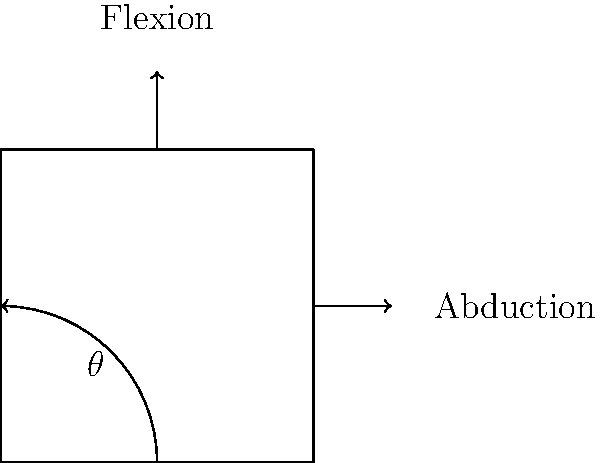In the context of online therapy using digital devices, what is the typical range of motion (ROM) for wrist flexion and abduction when interacting with a smartphone or tablet? How might this impact the effectiveness of hand exercises or gestures used in digital therapy interventions? To answer this question, we need to consider the biomechanics of wrist movements during interaction with digital devices:

1. Wrist Flexion:
   - Normal ROM: Approximately 60-80 degrees
   - When using a smartphone or tablet: Typically 10-30 degrees
   - Reduced ROM due to device support and ergonomic constraints

2. Wrist Abduction:
   - Normal ROM: Approximately 15-20 degrees (radial deviation) and 30-35 degrees (ulnar deviation)
   - When using a smartphone or tablet: Typically 5-15 degrees
   - Reduced ROM due to device size and grip requirements

3. Impact on digital therapy interventions:
   a) Limited ROM may restrict the effectiveness of certain hand exercises
   b) Therapists need to design interventions within the constraints of device interaction
   c) Prolonged use in limited ROM may lead to fatigue or discomfort
   d) Exercises focusing on full ROM may be necessary to counteract limited device-based movements
   e) Awareness of these limitations can help in developing more effective online therapy protocols

The typical ROM during device interaction is approximately 10-30 degrees for flexion and 5-15 degrees for abduction, which is significantly less than the full physiological ROM. This reduction can impact the effectiveness of hand exercises or gestures in digital therapy interventions, necessitating careful design of therapeutic activities and compensatory exercises.
Answer: Flexion: 10-30°, Abduction: 5-15°; reduced ROM may limit exercise effectiveness, requiring adapted intervention design. 